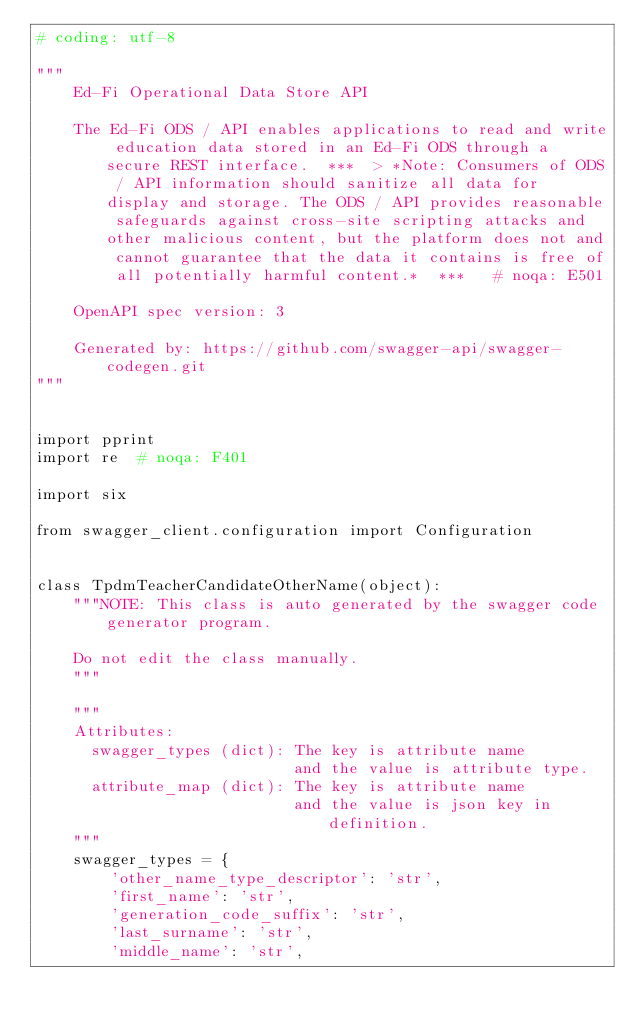<code> <loc_0><loc_0><loc_500><loc_500><_Python_># coding: utf-8

"""
    Ed-Fi Operational Data Store API

    The Ed-Fi ODS / API enables applications to read and write education data stored in an Ed-Fi ODS through a secure REST interface.  ***  > *Note: Consumers of ODS / API information should sanitize all data for display and storage. The ODS / API provides reasonable safeguards against cross-site scripting attacks and other malicious content, but the platform does not and cannot guarantee that the data it contains is free of all potentially harmful content.*  ***   # noqa: E501

    OpenAPI spec version: 3
    
    Generated by: https://github.com/swagger-api/swagger-codegen.git
"""


import pprint
import re  # noqa: F401

import six

from swagger_client.configuration import Configuration


class TpdmTeacherCandidateOtherName(object):
    """NOTE: This class is auto generated by the swagger code generator program.

    Do not edit the class manually.
    """

    """
    Attributes:
      swagger_types (dict): The key is attribute name
                            and the value is attribute type.
      attribute_map (dict): The key is attribute name
                            and the value is json key in definition.
    """
    swagger_types = {
        'other_name_type_descriptor': 'str',
        'first_name': 'str',
        'generation_code_suffix': 'str',
        'last_surname': 'str',
        'middle_name': 'str',</code> 